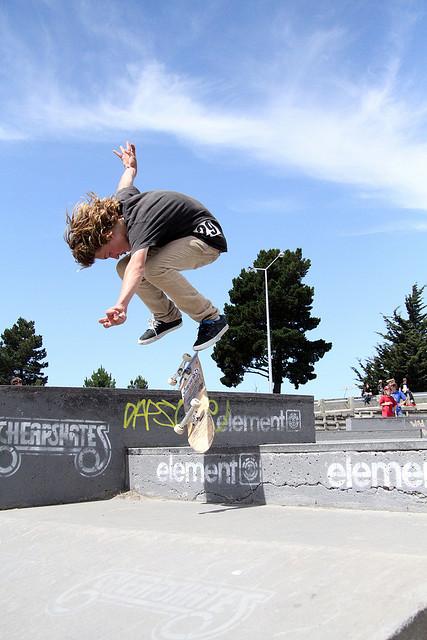Which direction is the person facing?
Write a very short answer. Down. Is this person in the air?
Be succinct. Yes. What is the boy doing?
Answer briefly. Skateboarding. 